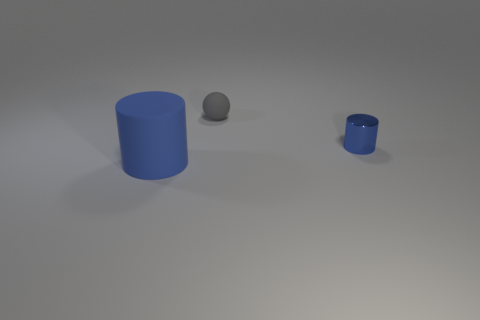How does the lighting in the image affect the appearance of the objects? The lighting in the image casts soft shadows to the right of the objects, highlighting their three-dimensional forms. The effect on the metallic objects is more pronounced as it reflects the light, giving them a shiny appearance, while the matte surface of the larger cylinder diffuses the light more evenly. 